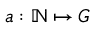<formula> <loc_0><loc_0><loc_500><loc_500>a \colon \mathbb { N } \mapsto G</formula> 